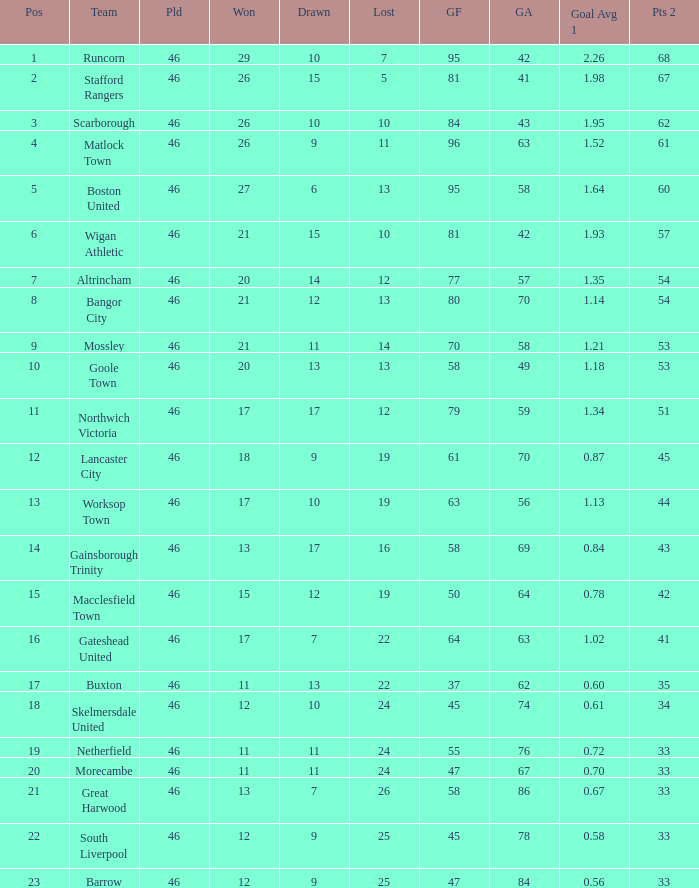What is the highest position of the Bangor City team? 8.0. 